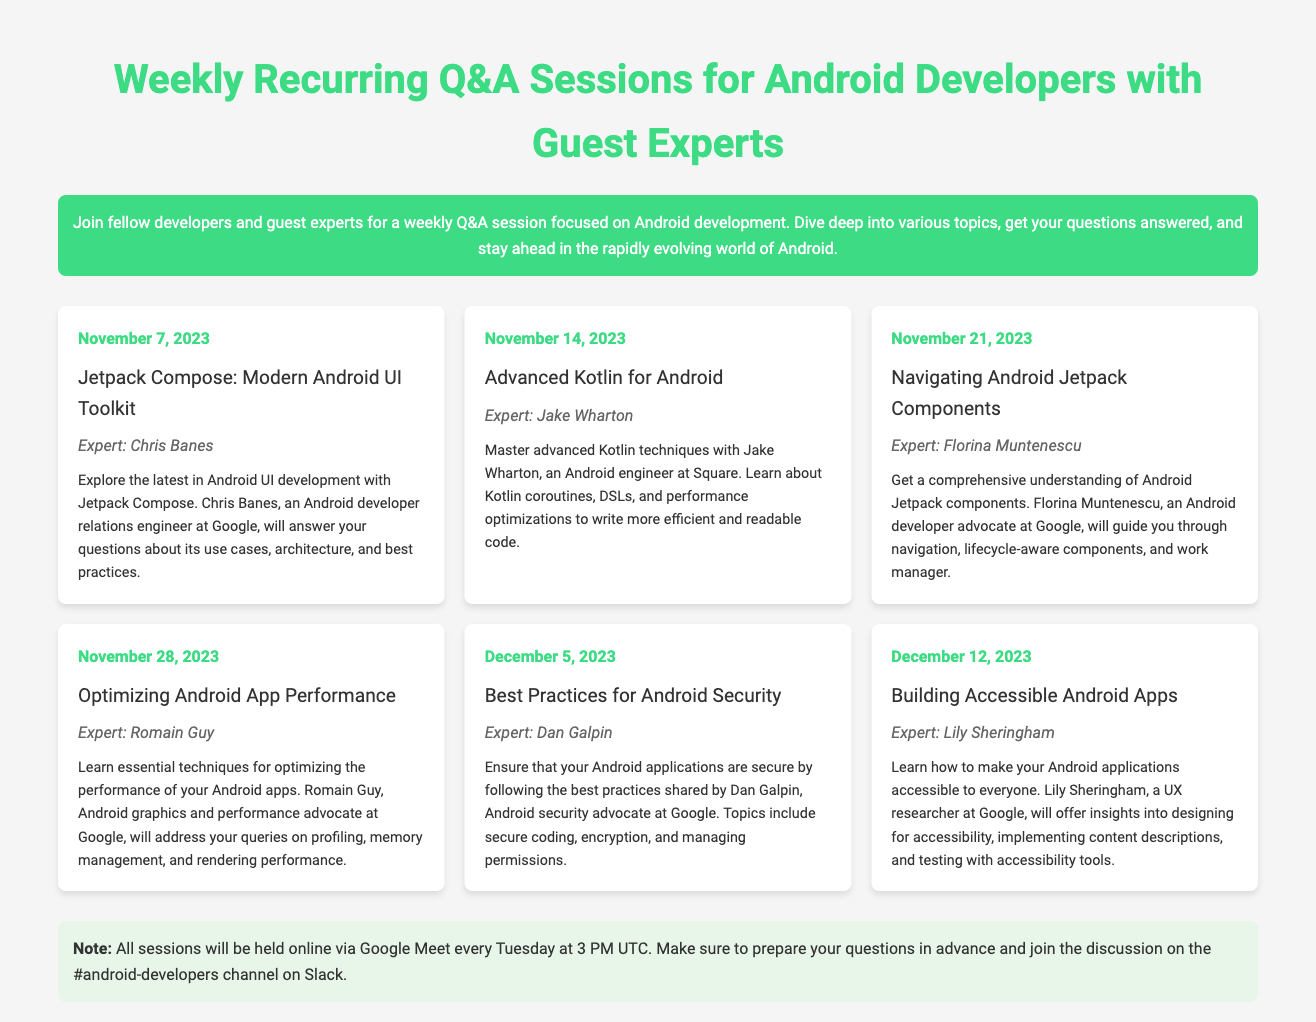What is the date of the first Q&A session? The first Q&A session is scheduled for November 7, 2023.
Answer: November 7, 2023 Who is the expert for the session on Advanced Kotlin for Android? The expert for the Advanced Kotlin for Android session is Jake Wharton.
Answer: Jake Wharton What is the main topic of the session on November 28, 2023? The main topic of the session on November 28, 2023, is Optimizing Android App Performance.
Answer: Optimizing Android App Performance How many sessions are scheduled in total? There are a total of six sessions scheduled according to the document.
Answer: Six What time will the sessions be held? The sessions will be held at 3 PM UTC every Tuesday.
Answer: 3 PM UTC Who is the expert for the session on Best Practices for Android Security? The expert for the Best Practices for Android Security session is Dan Galpin.
Answer: Dan Galpin What is the platform for the sessions? The sessions will be held online via Google Meet.
Answer: Google Meet What is the focus of the session on Building Accessible Android Apps? The focus of the session is to make Android applications accessible to everyone.
Answer: Accessible to everyone 